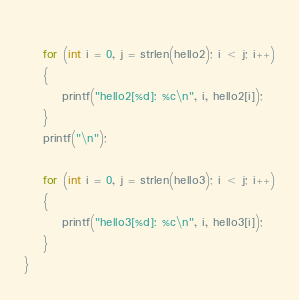<code> <loc_0><loc_0><loc_500><loc_500><_C_>    
    for (int i = 0, j = strlen(hello2); i < j; i++)
    {
        printf("hello2[%d]: %c\n", i, hello2[i]);
    }
    printf("\n");
    
    for (int i = 0, j = strlen(hello3); i < j; i++)
    {
        printf("hello3[%d]: %c\n", i, hello3[i]);
    }
}</code> 